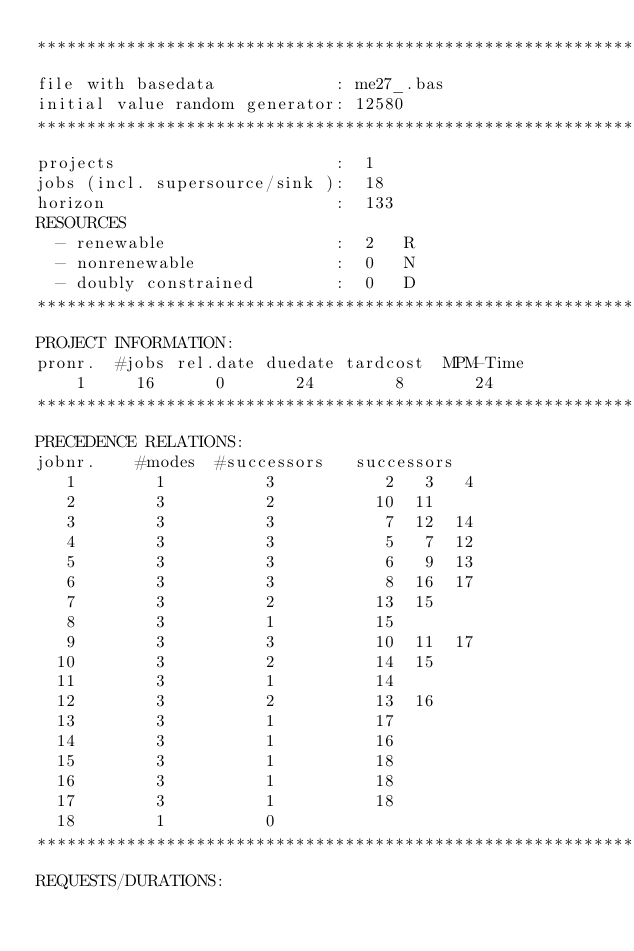Convert code to text. <code><loc_0><loc_0><loc_500><loc_500><_ObjectiveC_>************************************************************************
file with basedata            : me27_.bas
initial value random generator: 12580
************************************************************************
projects                      :  1
jobs (incl. supersource/sink ):  18
horizon                       :  133
RESOURCES
  - renewable                 :  2   R
  - nonrenewable              :  0   N
  - doubly constrained        :  0   D
************************************************************************
PROJECT INFORMATION:
pronr.  #jobs rel.date duedate tardcost  MPM-Time
    1     16      0       24        8       24
************************************************************************
PRECEDENCE RELATIONS:
jobnr.    #modes  #successors   successors
   1        1          3           2   3   4
   2        3          2          10  11
   3        3          3           7  12  14
   4        3          3           5   7  12
   5        3          3           6   9  13
   6        3          3           8  16  17
   7        3          2          13  15
   8        3          1          15
   9        3          3          10  11  17
  10        3          2          14  15
  11        3          1          14
  12        3          2          13  16
  13        3          1          17
  14        3          1          16
  15        3          1          18
  16        3          1          18
  17        3          1          18
  18        1          0        
************************************************************************
REQUESTS/DURATIONS:</code> 